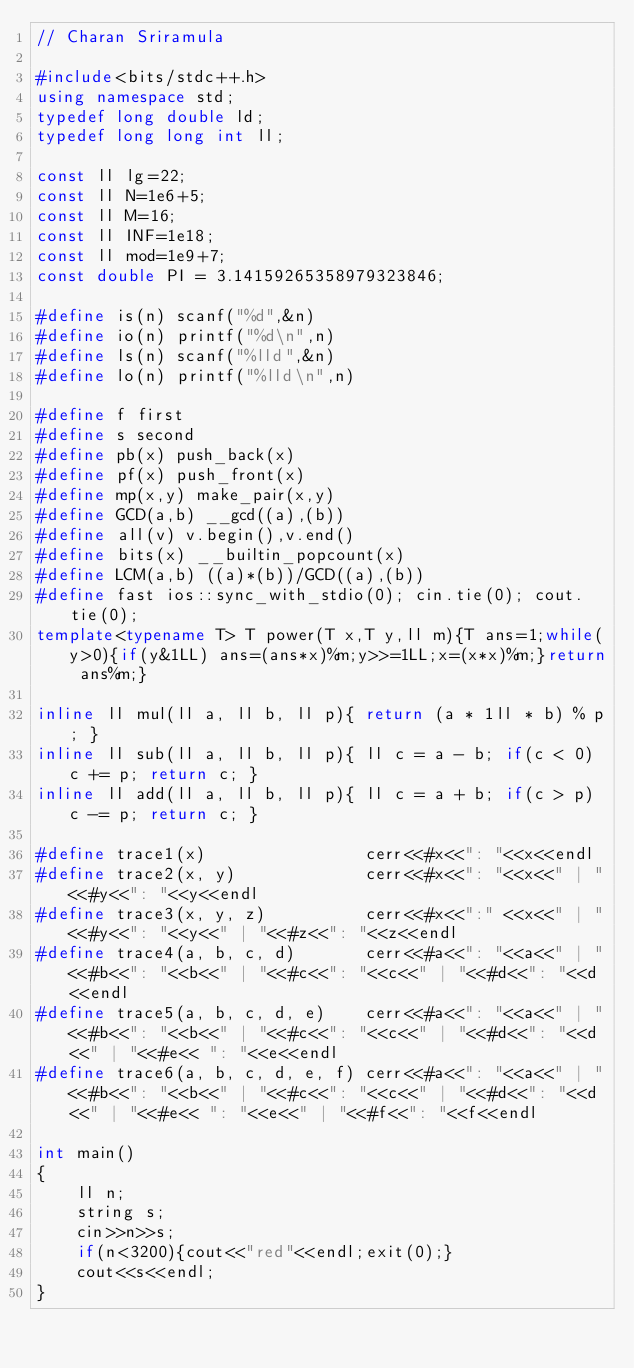<code> <loc_0><loc_0><loc_500><loc_500><_C++_>// Charan Sriramula
 
#include<bits/stdc++.h>
using namespace std;
typedef long double ld;
typedef long long int ll;
 
const ll lg=22;
const ll N=1e6+5;
const ll M=16;
const ll INF=1e18;
const ll mod=1e9+7;
const double PI = 3.14159265358979323846;
 
#define is(n) scanf("%d",&n)
#define io(n) printf("%d\n",n)
#define ls(n) scanf("%lld",&n)
#define lo(n) printf("%lld\n",n)
 
#define f first
#define s second
#define pb(x) push_back(x)
#define pf(x) push_front(x)
#define mp(x,y) make_pair(x,y)
#define GCD(a,b) __gcd((a),(b))
#define all(v) v.begin(),v.end()
#define bits(x) __builtin_popcount(x)
#define LCM(a,b) ((a)*(b))/GCD((a),(b))
#define fast ios::sync_with_stdio(0); cin.tie(0); cout.tie(0);
template<typename T> T power(T x,T y,ll m){T ans=1;while(y>0){if(y&1LL) ans=(ans*x)%m;y>>=1LL;x=(x*x)%m;}return ans%m;}
 
inline ll mul(ll a, ll b, ll p){ return (a * 1ll * b) % p; }
inline ll sub(ll a, ll b, ll p){ ll c = a - b; if(c < 0) c += p; return c; }
inline ll add(ll a, ll b, ll p){ ll c = a + b; if(c > p) c -= p; return c; }
 
#define trace1(x)                cerr<<#x<<": "<<x<<endl
#define trace2(x, y)             cerr<<#x<<": "<<x<<" | "<<#y<<": "<<y<<endl
#define trace3(x, y, z)          cerr<<#x<<":" <<x<<" | "<<#y<<": "<<y<<" | "<<#z<<": "<<z<<endl
#define trace4(a, b, c, d)       cerr<<#a<<": "<<a<<" | "<<#b<<": "<<b<<" | "<<#c<<": "<<c<<" | "<<#d<<": "<<d<<endl
#define trace5(a, b, c, d, e)    cerr<<#a<<": "<<a<<" | "<<#b<<": "<<b<<" | "<<#c<<": "<<c<<" | "<<#d<<": "<<d<<" | "<<#e<< ": "<<e<<endl
#define trace6(a, b, c, d, e, f) cerr<<#a<<": "<<a<<" | "<<#b<<": "<<b<<" | "<<#c<<": "<<c<<" | "<<#d<<": "<<d<<" | "<<#e<< ": "<<e<<" | "<<#f<<": "<<f<<endl
 
int main()
{
    ll n;
    string s;
    cin>>n>>s;
    if(n<3200){cout<<"red"<<endl;exit(0);}
    cout<<s<<endl;
}</code> 